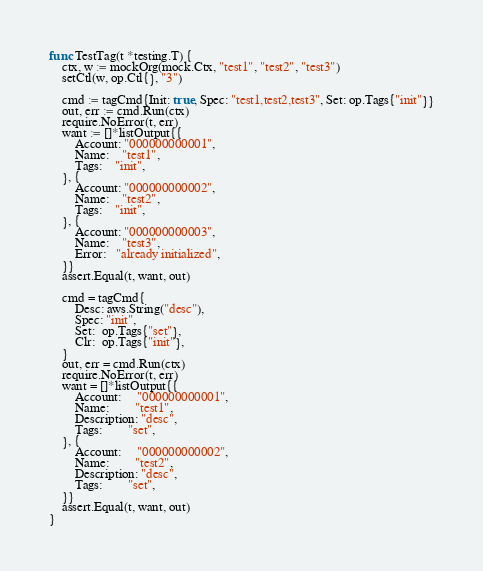Convert code to text. <code><loc_0><loc_0><loc_500><loc_500><_Go_>
func TestTag(t *testing.T) {
	ctx, w := mockOrg(mock.Ctx, "test1", "test2", "test3")
	setCtl(w, op.Ctl{}, "3")

	cmd := tagCmd{Init: true, Spec: "test1,test2,test3", Set: op.Tags{"init"}}
	out, err := cmd.Run(ctx)
	require.NoError(t, err)
	want := []*listOutput{{
		Account: "000000000001",
		Name:    "test1",
		Tags:    "init",
	}, {
		Account: "000000000002",
		Name:    "test2",
		Tags:    "init",
	}, {
		Account: "000000000003",
		Name:    "test3",
		Error:   "already initialized",
	}}
	assert.Equal(t, want, out)

	cmd = tagCmd{
		Desc: aws.String("desc"),
		Spec: "init",
		Set:  op.Tags{"set"},
		Clr:  op.Tags{"init"},
	}
	out, err = cmd.Run(ctx)
	require.NoError(t, err)
	want = []*listOutput{{
		Account:     "000000000001",
		Name:        "test1",
		Description: "desc",
		Tags:        "set",
	}, {
		Account:     "000000000002",
		Name:        "test2",
		Description: "desc",
		Tags:        "set",
	}}
	assert.Equal(t, want, out)
}
</code> 